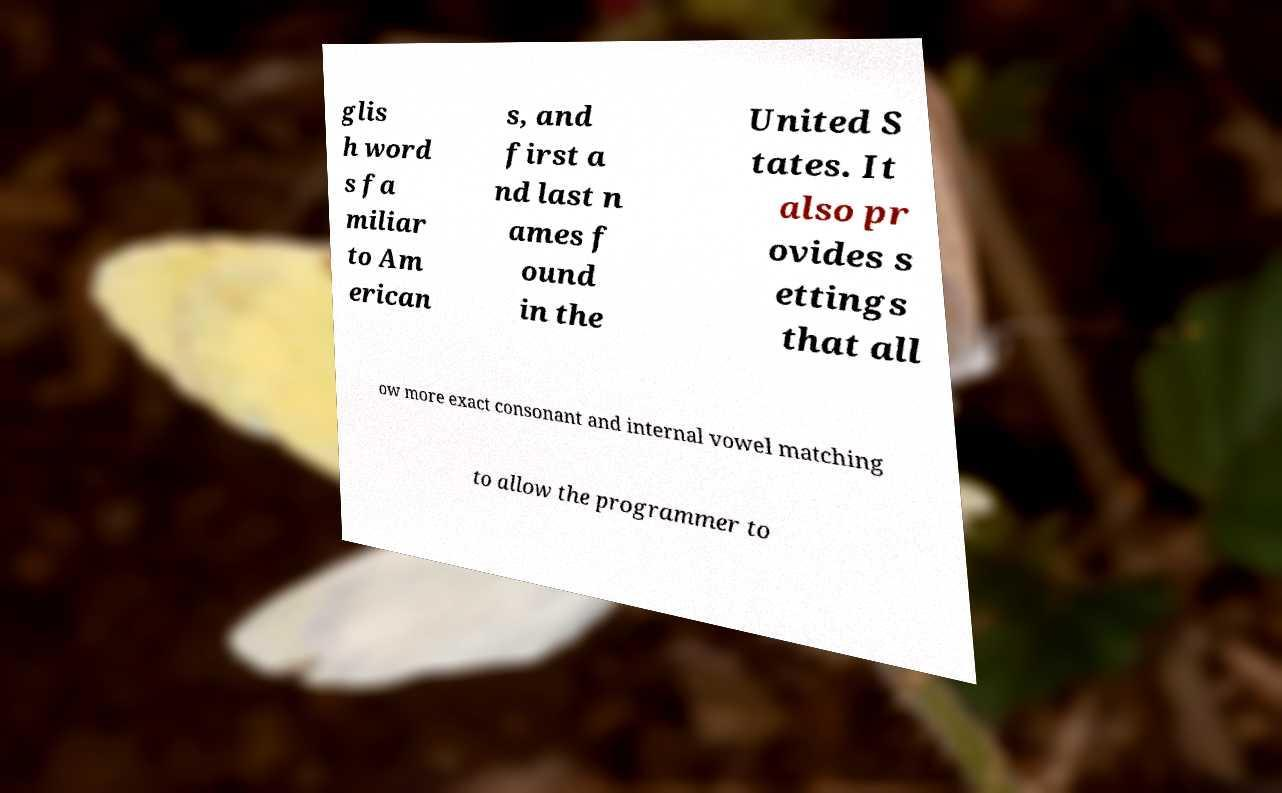Please identify and transcribe the text found in this image. glis h word s fa miliar to Am erican s, and first a nd last n ames f ound in the United S tates. It also pr ovides s ettings that all ow more exact consonant and internal vowel matching to allow the programmer to 